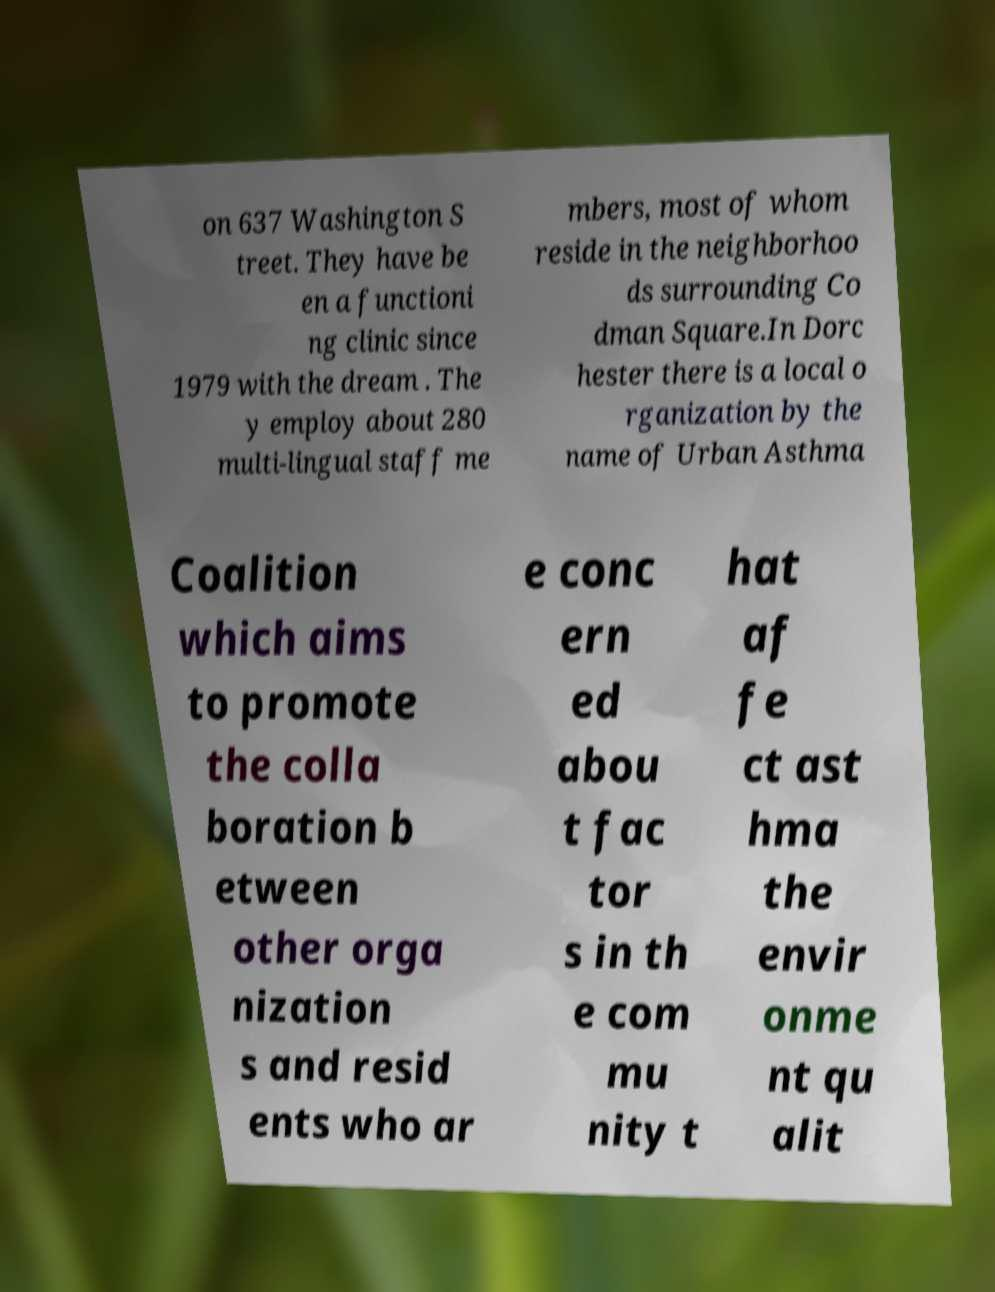Can you read and provide the text displayed in the image?This photo seems to have some interesting text. Can you extract and type it out for me? on 637 Washington S treet. They have be en a functioni ng clinic since 1979 with the dream . The y employ about 280 multi-lingual staff me mbers, most of whom reside in the neighborhoo ds surrounding Co dman Square.In Dorc hester there is a local o rganization by the name of Urban Asthma Coalition which aims to promote the colla boration b etween other orga nization s and resid ents who ar e conc ern ed abou t fac tor s in th e com mu nity t hat af fe ct ast hma the envir onme nt qu alit 